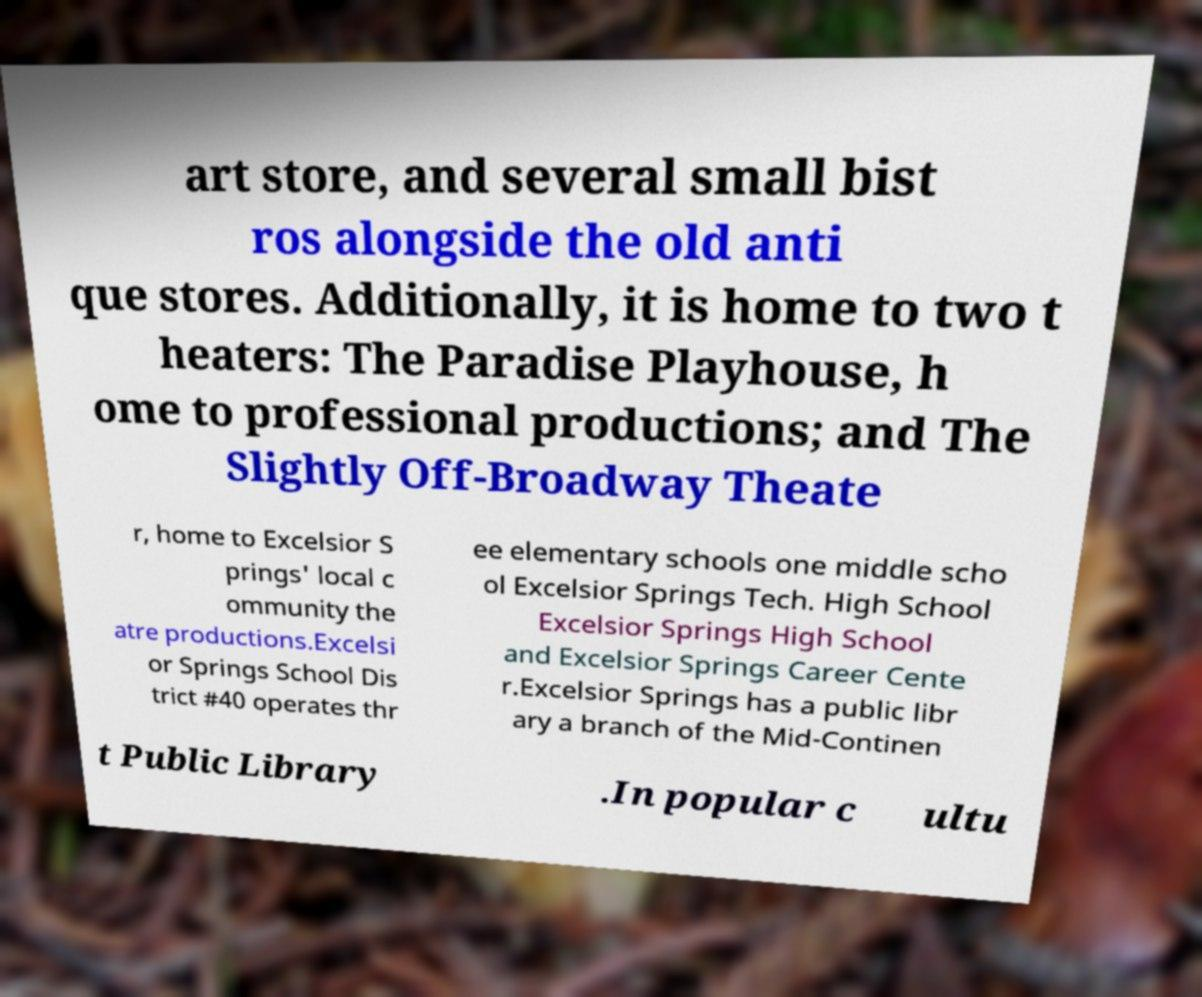Could you assist in decoding the text presented in this image and type it out clearly? art store, and several small bist ros alongside the old anti que stores. Additionally, it is home to two t heaters: The Paradise Playhouse, h ome to professional productions; and The Slightly Off-Broadway Theate r, home to Excelsior S prings' local c ommunity the atre productions.Excelsi or Springs School Dis trict #40 operates thr ee elementary schools one middle scho ol Excelsior Springs Tech. High School Excelsior Springs High School and Excelsior Springs Career Cente r.Excelsior Springs has a public libr ary a branch of the Mid-Continen t Public Library .In popular c ultu 